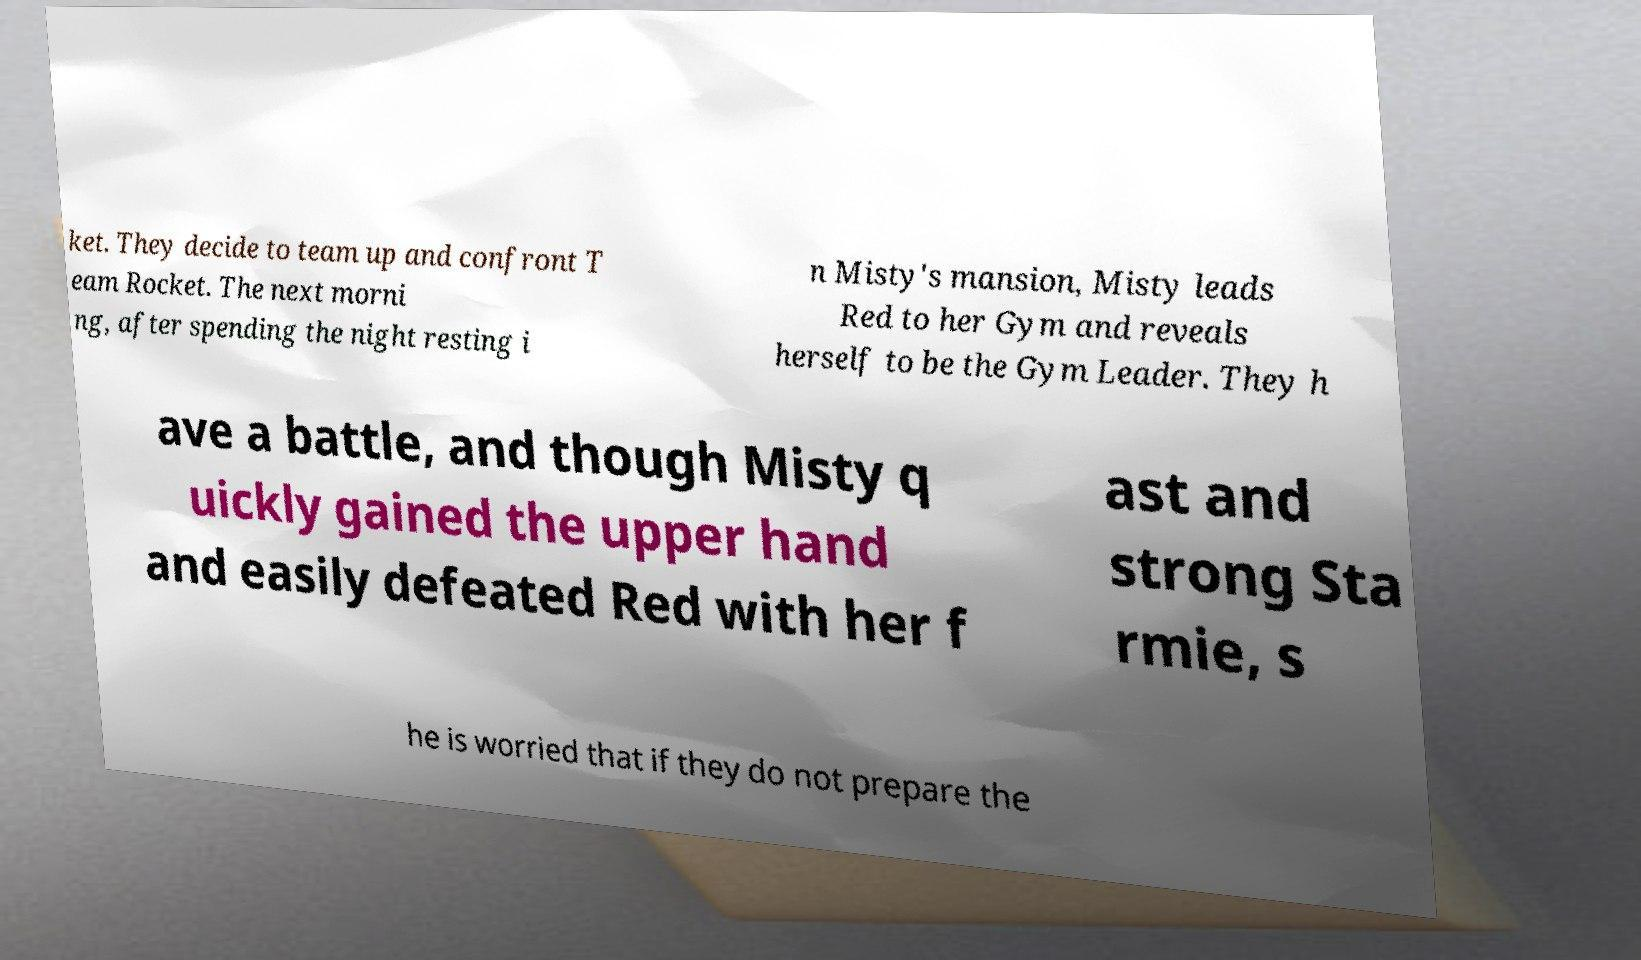What messages or text are displayed in this image? I need them in a readable, typed format. ket. They decide to team up and confront T eam Rocket. The next morni ng, after spending the night resting i n Misty's mansion, Misty leads Red to her Gym and reveals herself to be the Gym Leader. They h ave a battle, and though Misty q uickly gained the upper hand and easily defeated Red with her f ast and strong Sta rmie, s he is worried that if they do not prepare the 